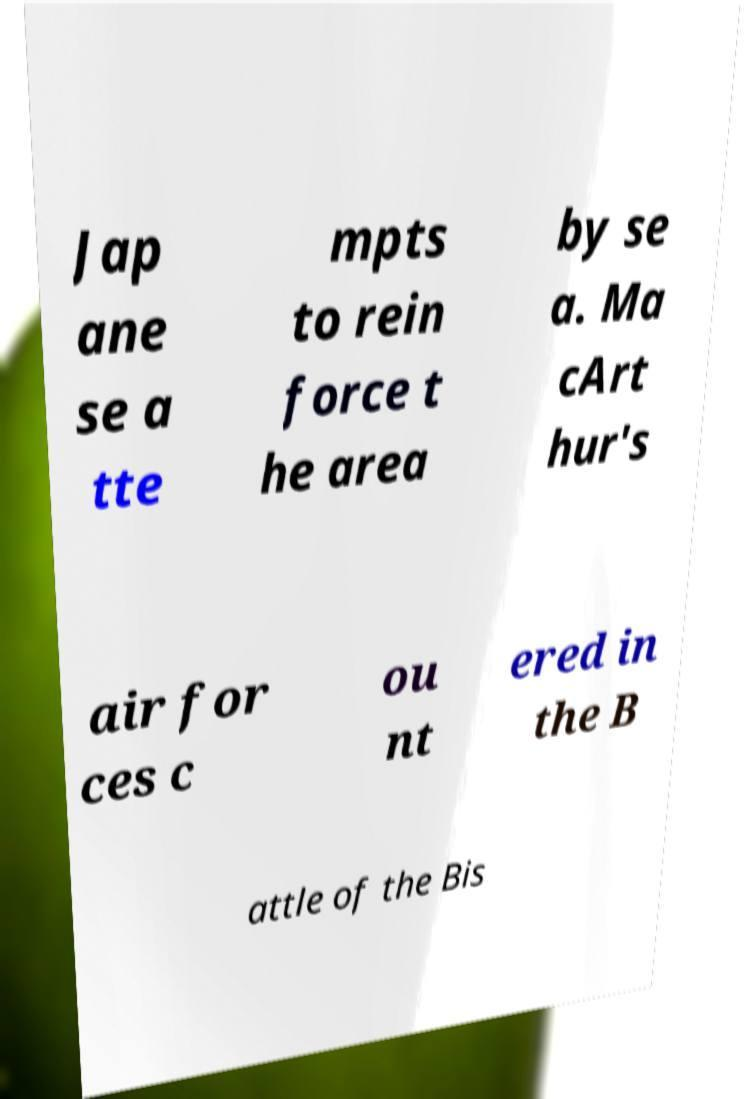Could you extract and type out the text from this image? Jap ane se a tte mpts to rein force t he area by se a. Ma cArt hur's air for ces c ou nt ered in the B attle of the Bis 